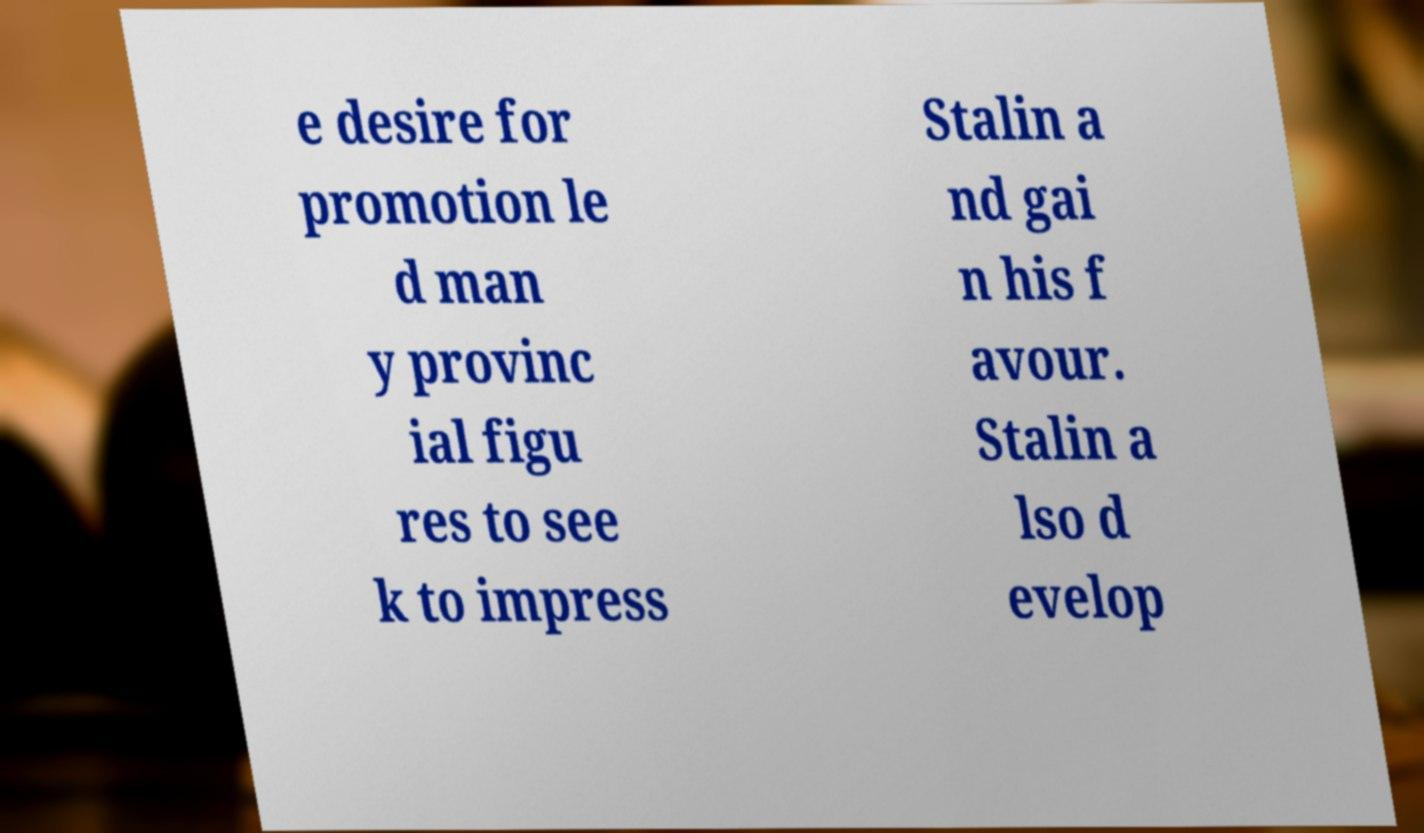There's text embedded in this image that I need extracted. Can you transcribe it verbatim? e desire for promotion le d man y provinc ial figu res to see k to impress Stalin a nd gai n his f avour. Stalin a lso d evelop 